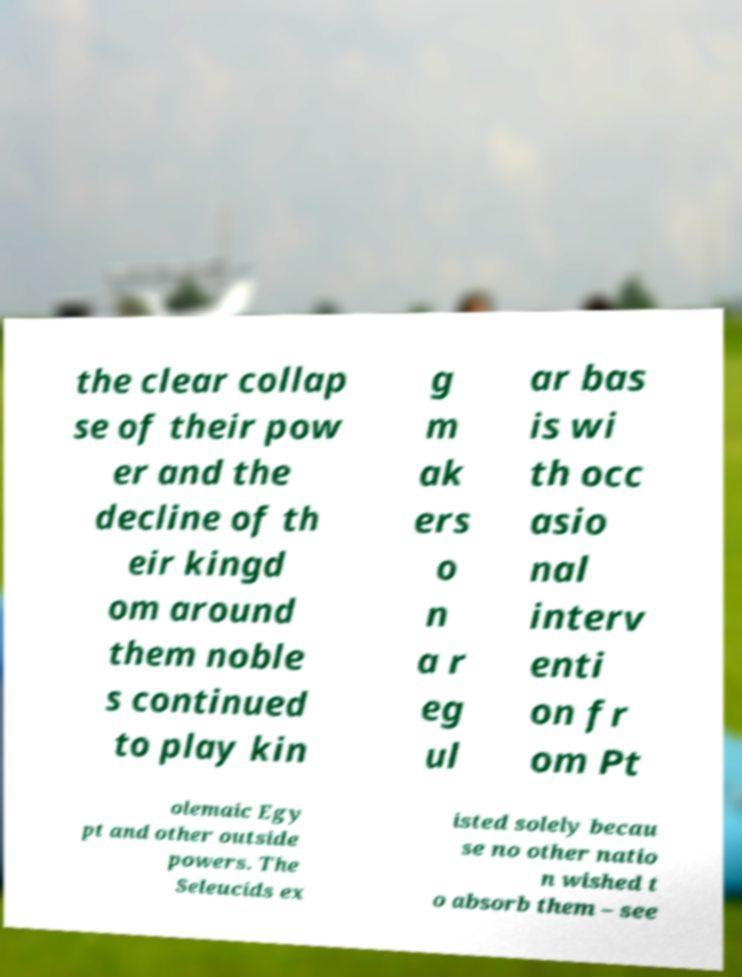Could you extract and type out the text from this image? the clear collap se of their pow er and the decline of th eir kingd om around them noble s continued to play kin g m ak ers o n a r eg ul ar bas is wi th occ asio nal interv enti on fr om Pt olemaic Egy pt and other outside powers. The Seleucids ex isted solely becau se no other natio n wished t o absorb them – see 